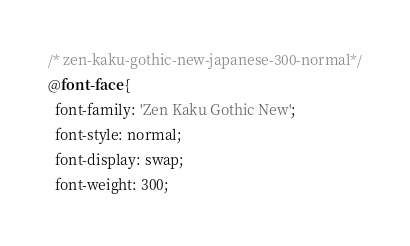<code> <loc_0><loc_0><loc_500><loc_500><_CSS_>/* zen-kaku-gothic-new-japanese-300-normal*/
@font-face {
  font-family: 'Zen Kaku Gothic New';
  font-style: normal;
  font-display: swap;
  font-weight: 300;</code> 